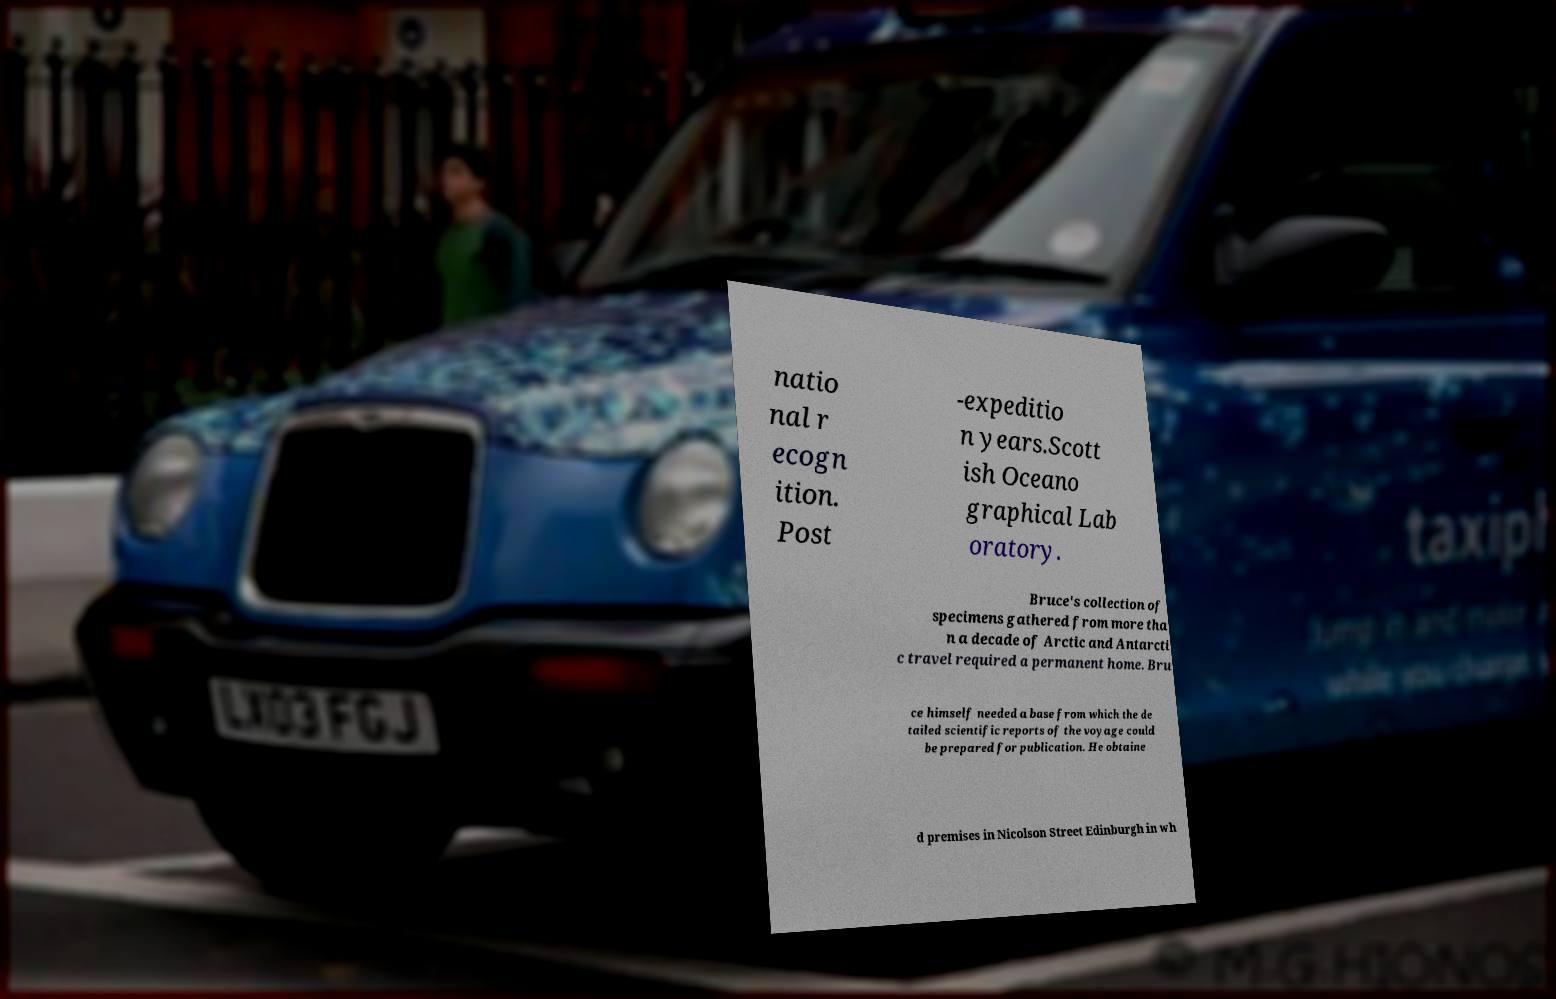Please identify and transcribe the text found in this image. natio nal r ecogn ition. Post -expeditio n years.Scott ish Oceano graphical Lab oratory. Bruce's collection of specimens gathered from more tha n a decade of Arctic and Antarcti c travel required a permanent home. Bru ce himself needed a base from which the de tailed scientific reports of the voyage could be prepared for publication. He obtaine d premises in Nicolson Street Edinburgh in wh 